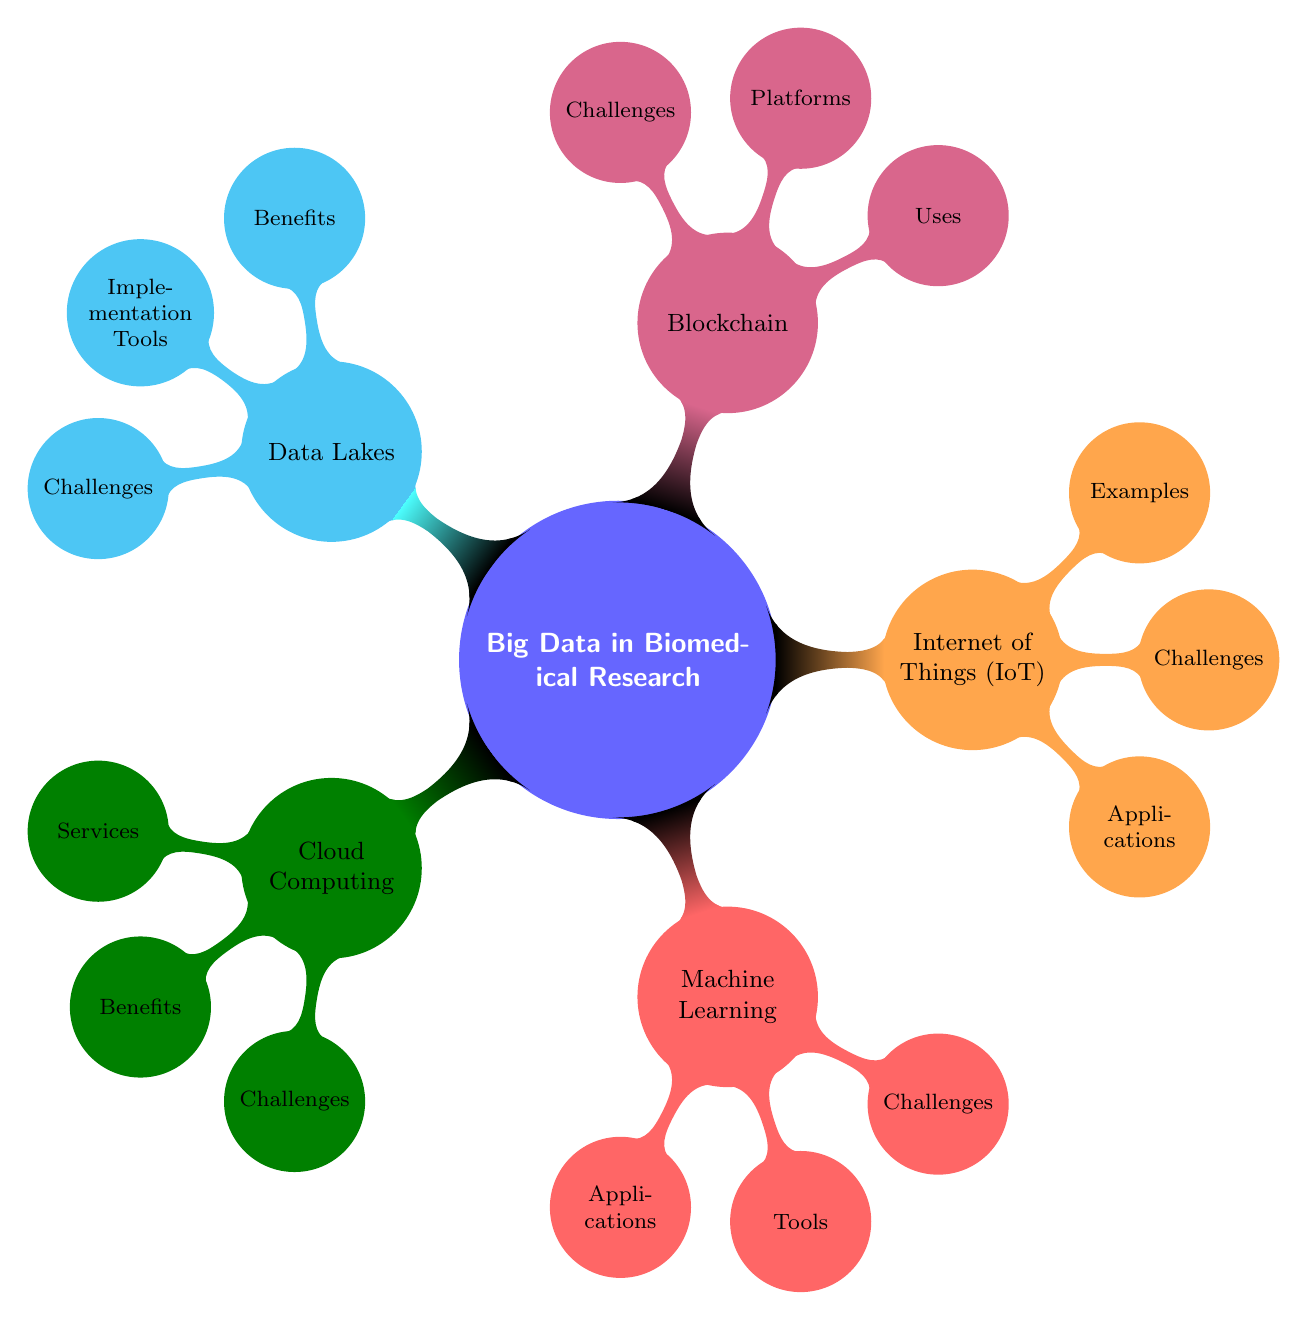What is one benefit of cloud computing? The diagram indicates that one of the benefits of cloud computing is "Cost Efficiency." This is a direct answer found in the benefits associated with the Cloud Computing node.
Answer: Cost Efficiency How many main technologies are listed under big data in biomedical research? The diagram explicitly shows five main technologies under big data in biomedical research: Cloud Computing, Machine Learning, Internet of Things (IoT), Blockchain, and Data Lakes. Therefore, by counting these nodes, we find there are five.
Answer: Five Which platform is listed under blockchain? The diagram specifies "Ethereum" as one of the platforms listed under the Blockchain node, highlighting its inclusion in the relevant section.
Answer: Ethereum What is a challenge faced by both cloud computing and data lakes? To find a common challenge, we can examine the challenges section under both Cloud Computing and Data Lakes. Both indicate "Data Security" for cloud computing and "Data Governance" for data lakes, but a more general term like "Integration Complexity" for Data Lakes does not apply to Cloud Computing, while "Compliance with Regulations" for Cloud Computing is not listed under Data Lakes. The answer then focuses on "Data Quality," which is a challenge shared by both Machine Learning and Data Lakes primarily.
Answer: Data Quality Name one application of the Internet of Things (IoT). The diagram lists specific applications under the IoT node, and one of them includes "Remote Patient Monitoring," providing a direct answer to this question.
Answer: Remote Patient Monitoring Which technology addresses data provenance? The diagram indicates that "data provenance" is one of the uses of blockchain technology, pointing to its specific consideration in managing biomedical research data.
Answer: Blockchain What are two tools used in machine learning? The diagram includes a list of tools under the Machine Learning node, specifically naming "TensorFlow" and "scikit-learn" as two examples of tools used for machine learning, answering the question directly from the diagram.
Answer: TensorFlow, scikit-learn What is a challenge of using Internet of Things (IoT) technology? The challenges associated with IoT are listed under the IoT node, and "Data Privacy" is highlighted as one of the challenges, thus providing a direct answer based on the diagram.
Answer: Data Privacy 